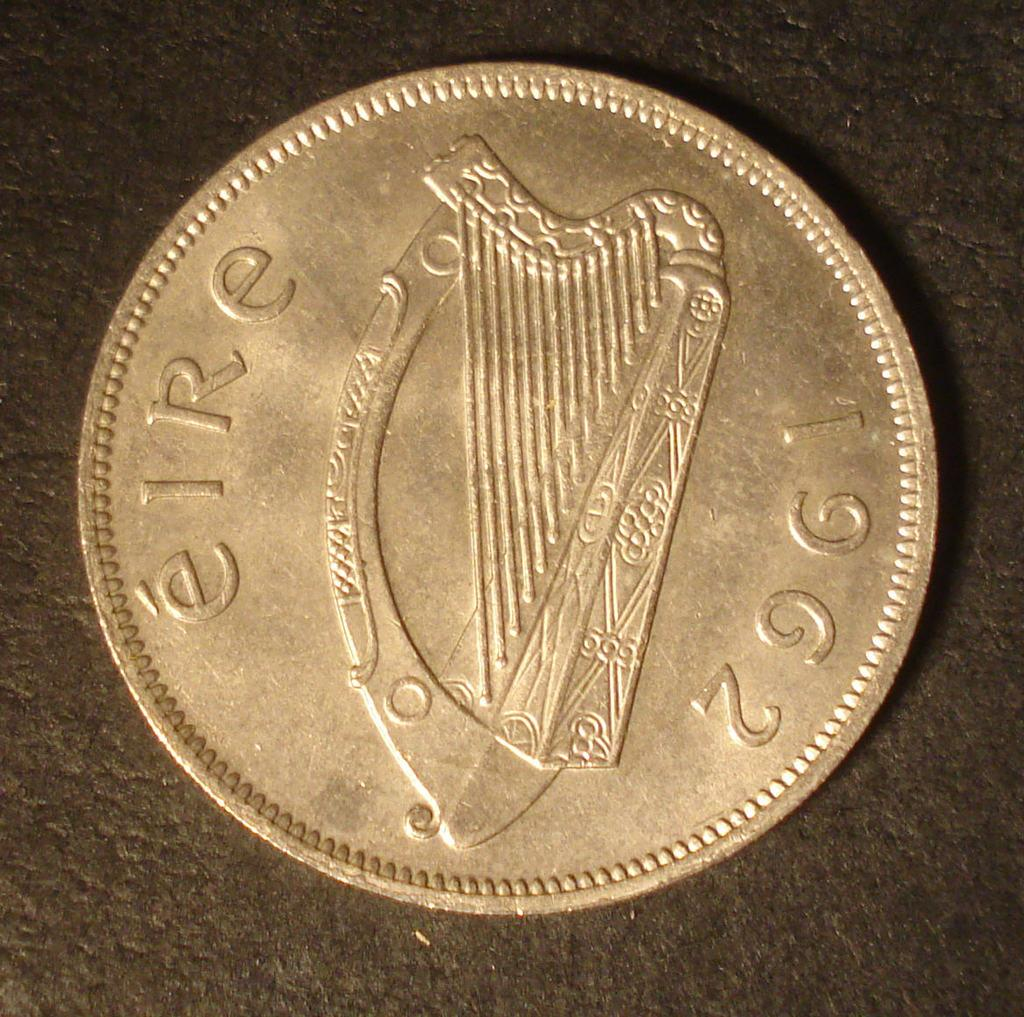<image>
Summarize the visual content of the image. Gold coin with a harp design and the lettering of eire 1962 